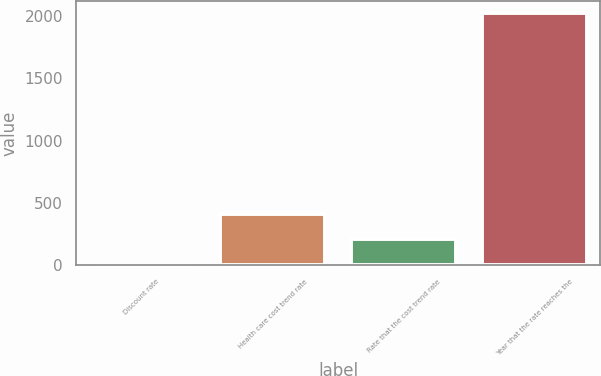Convert chart. <chart><loc_0><loc_0><loc_500><loc_500><bar_chart><fcel>Discount rate<fcel>Health care cost trend rate<fcel>Rate that the cost trend rate<fcel>Year that the rate reaches the<nl><fcel>3.9<fcel>407.52<fcel>205.71<fcel>2022<nl></chart> 